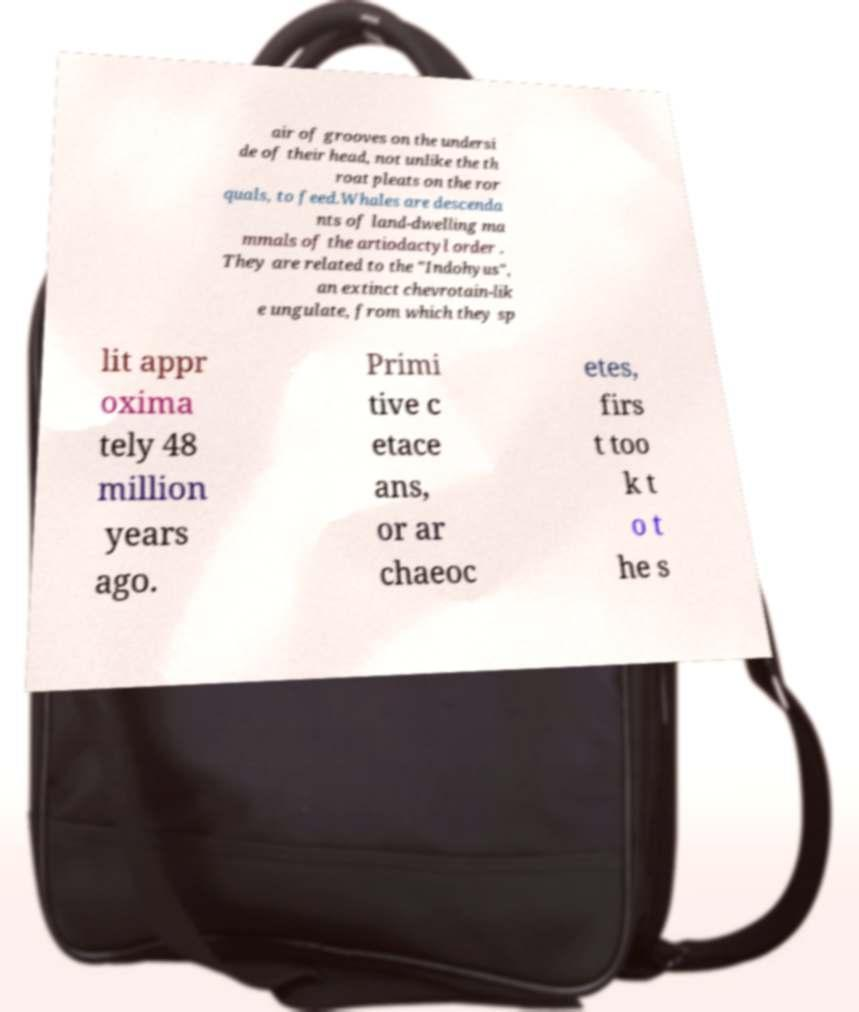Please identify and transcribe the text found in this image. air of grooves on the undersi de of their head, not unlike the th roat pleats on the ror quals, to feed.Whales are descenda nts of land-dwelling ma mmals of the artiodactyl order . They are related to the "Indohyus", an extinct chevrotain-lik e ungulate, from which they sp lit appr oxima tely 48 million years ago. Primi tive c etace ans, or ar chaeoc etes, firs t too k t o t he s 